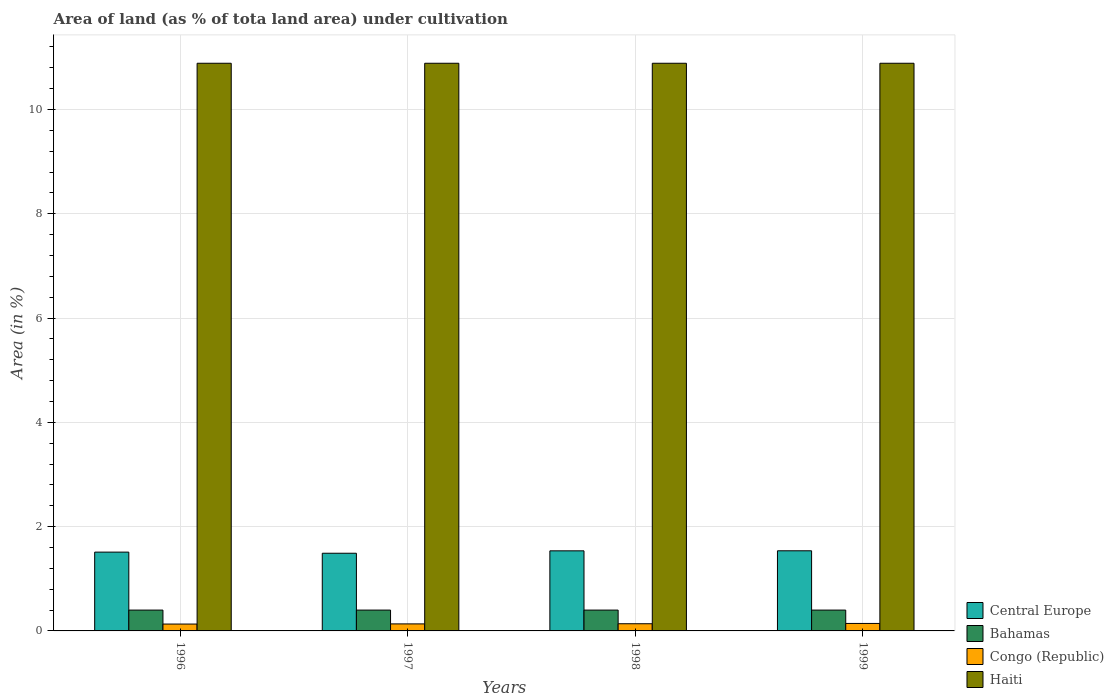How many groups of bars are there?
Provide a short and direct response. 4. Are the number of bars per tick equal to the number of legend labels?
Make the answer very short. Yes. Are the number of bars on each tick of the X-axis equal?
Provide a short and direct response. Yes. How many bars are there on the 2nd tick from the right?
Give a very brief answer. 4. What is the percentage of land under cultivation in Bahamas in 1998?
Keep it short and to the point. 0.4. Across all years, what is the maximum percentage of land under cultivation in Haiti?
Offer a terse response. 10.89. Across all years, what is the minimum percentage of land under cultivation in Central Europe?
Provide a succinct answer. 1.49. In which year was the percentage of land under cultivation in Congo (Republic) maximum?
Offer a terse response. 1999. In which year was the percentage of land under cultivation in Haiti minimum?
Offer a terse response. 1996. What is the total percentage of land under cultivation in Bahamas in the graph?
Offer a very short reply. 1.6. What is the difference between the percentage of land under cultivation in Bahamas in 1996 and that in 1997?
Ensure brevity in your answer.  0. What is the difference between the percentage of land under cultivation in Bahamas in 1998 and the percentage of land under cultivation in Central Europe in 1999?
Your answer should be compact. -1.14. What is the average percentage of land under cultivation in Congo (Republic) per year?
Your response must be concise. 0.14. In the year 1998, what is the difference between the percentage of land under cultivation in Central Europe and percentage of land under cultivation in Bahamas?
Provide a succinct answer. 1.14. What is the ratio of the percentage of land under cultivation in Bahamas in 1997 to that in 1999?
Offer a terse response. 1. What is the difference between the highest and the second highest percentage of land under cultivation in Haiti?
Keep it short and to the point. 0. What is the difference between the highest and the lowest percentage of land under cultivation in Central Europe?
Make the answer very short. 0.05. In how many years, is the percentage of land under cultivation in Congo (Republic) greater than the average percentage of land under cultivation in Congo (Republic) taken over all years?
Offer a very short reply. 2. Is it the case that in every year, the sum of the percentage of land under cultivation in Haiti and percentage of land under cultivation in Central Europe is greater than the sum of percentage of land under cultivation in Bahamas and percentage of land under cultivation in Congo (Republic)?
Your response must be concise. Yes. What does the 4th bar from the left in 1997 represents?
Provide a short and direct response. Haiti. What does the 1st bar from the right in 1997 represents?
Provide a short and direct response. Haiti. Are all the bars in the graph horizontal?
Your answer should be compact. No. What is the difference between two consecutive major ticks on the Y-axis?
Your answer should be compact. 2. Are the values on the major ticks of Y-axis written in scientific E-notation?
Your answer should be compact. No. Does the graph contain grids?
Your answer should be very brief. Yes. What is the title of the graph?
Your response must be concise. Area of land (as % of tota land area) under cultivation. What is the label or title of the X-axis?
Offer a terse response. Years. What is the label or title of the Y-axis?
Your answer should be compact. Area (in %). What is the Area (in %) in Central Europe in 1996?
Provide a succinct answer. 1.51. What is the Area (in %) of Bahamas in 1996?
Your response must be concise. 0.4. What is the Area (in %) in Congo (Republic) in 1996?
Offer a very short reply. 0.13. What is the Area (in %) of Haiti in 1996?
Your response must be concise. 10.89. What is the Area (in %) of Central Europe in 1997?
Offer a very short reply. 1.49. What is the Area (in %) in Bahamas in 1997?
Offer a very short reply. 0.4. What is the Area (in %) of Congo (Republic) in 1997?
Keep it short and to the point. 0.13. What is the Area (in %) of Haiti in 1997?
Give a very brief answer. 10.89. What is the Area (in %) of Central Europe in 1998?
Make the answer very short. 1.54. What is the Area (in %) in Bahamas in 1998?
Ensure brevity in your answer.  0.4. What is the Area (in %) in Congo (Republic) in 1998?
Offer a very short reply. 0.14. What is the Area (in %) of Haiti in 1998?
Your answer should be very brief. 10.89. What is the Area (in %) of Central Europe in 1999?
Ensure brevity in your answer.  1.54. What is the Area (in %) in Bahamas in 1999?
Ensure brevity in your answer.  0.4. What is the Area (in %) in Congo (Republic) in 1999?
Offer a very short reply. 0.14. What is the Area (in %) of Haiti in 1999?
Your answer should be very brief. 10.89. Across all years, what is the maximum Area (in %) of Central Europe?
Your answer should be compact. 1.54. Across all years, what is the maximum Area (in %) of Bahamas?
Your response must be concise. 0.4. Across all years, what is the maximum Area (in %) in Congo (Republic)?
Give a very brief answer. 0.14. Across all years, what is the maximum Area (in %) in Haiti?
Your response must be concise. 10.89. Across all years, what is the minimum Area (in %) of Central Europe?
Give a very brief answer. 1.49. Across all years, what is the minimum Area (in %) of Bahamas?
Provide a succinct answer. 0.4. Across all years, what is the minimum Area (in %) of Congo (Republic)?
Offer a very short reply. 0.13. Across all years, what is the minimum Area (in %) in Haiti?
Give a very brief answer. 10.89. What is the total Area (in %) in Central Europe in the graph?
Your response must be concise. 6.07. What is the total Area (in %) in Bahamas in the graph?
Provide a short and direct response. 1.6. What is the total Area (in %) in Congo (Republic) in the graph?
Make the answer very short. 0.55. What is the total Area (in %) of Haiti in the graph?
Provide a succinct answer. 43.54. What is the difference between the Area (in %) in Central Europe in 1996 and that in 1997?
Your answer should be very brief. 0.02. What is the difference between the Area (in %) of Congo (Republic) in 1996 and that in 1997?
Ensure brevity in your answer.  -0. What is the difference between the Area (in %) in Central Europe in 1996 and that in 1998?
Give a very brief answer. -0.02. What is the difference between the Area (in %) of Congo (Republic) in 1996 and that in 1998?
Your response must be concise. -0.01. What is the difference between the Area (in %) in Central Europe in 1996 and that in 1999?
Your answer should be compact. -0.03. What is the difference between the Area (in %) in Bahamas in 1996 and that in 1999?
Give a very brief answer. 0. What is the difference between the Area (in %) in Congo (Republic) in 1996 and that in 1999?
Offer a very short reply. -0.01. What is the difference between the Area (in %) of Haiti in 1996 and that in 1999?
Give a very brief answer. 0. What is the difference between the Area (in %) in Central Europe in 1997 and that in 1998?
Offer a terse response. -0.05. What is the difference between the Area (in %) in Bahamas in 1997 and that in 1998?
Your response must be concise. 0. What is the difference between the Area (in %) in Congo (Republic) in 1997 and that in 1998?
Offer a very short reply. -0. What is the difference between the Area (in %) in Central Europe in 1997 and that in 1999?
Your response must be concise. -0.05. What is the difference between the Area (in %) in Congo (Republic) in 1997 and that in 1999?
Offer a terse response. -0.01. What is the difference between the Area (in %) in Central Europe in 1998 and that in 1999?
Offer a terse response. -0. What is the difference between the Area (in %) of Bahamas in 1998 and that in 1999?
Provide a short and direct response. 0. What is the difference between the Area (in %) in Congo (Republic) in 1998 and that in 1999?
Make the answer very short. -0.01. What is the difference between the Area (in %) of Haiti in 1998 and that in 1999?
Provide a short and direct response. 0. What is the difference between the Area (in %) of Central Europe in 1996 and the Area (in %) of Bahamas in 1997?
Give a very brief answer. 1.11. What is the difference between the Area (in %) in Central Europe in 1996 and the Area (in %) in Congo (Republic) in 1997?
Provide a short and direct response. 1.38. What is the difference between the Area (in %) in Central Europe in 1996 and the Area (in %) in Haiti in 1997?
Give a very brief answer. -9.37. What is the difference between the Area (in %) of Bahamas in 1996 and the Area (in %) of Congo (Republic) in 1997?
Your answer should be very brief. 0.26. What is the difference between the Area (in %) of Bahamas in 1996 and the Area (in %) of Haiti in 1997?
Offer a very short reply. -10.49. What is the difference between the Area (in %) of Congo (Republic) in 1996 and the Area (in %) of Haiti in 1997?
Your response must be concise. -10.75. What is the difference between the Area (in %) in Central Europe in 1996 and the Area (in %) in Bahamas in 1998?
Your response must be concise. 1.11. What is the difference between the Area (in %) in Central Europe in 1996 and the Area (in %) in Congo (Republic) in 1998?
Your answer should be very brief. 1.37. What is the difference between the Area (in %) of Central Europe in 1996 and the Area (in %) of Haiti in 1998?
Keep it short and to the point. -9.37. What is the difference between the Area (in %) in Bahamas in 1996 and the Area (in %) in Congo (Republic) in 1998?
Ensure brevity in your answer.  0.26. What is the difference between the Area (in %) in Bahamas in 1996 and the Area (in %) in Haiti in 1998?
Provide a short and direct response. -10.49. What is the difference between the Area (in %) in Congo (Republic) in 1996 and the Area (in %) in Haiti in 1998?
Keep it short and to the point. -10.75. What is the difference between the Area (in %) in Central Europe in 1996 and the Area (in %) in Bahamas in 1999?
Keep it short and to the point. 1.11. What is the difference between the Area (in %) of Central Europe in 1996 and the Area (in %) of Congo (Republic) in 1999?
Your answer should be compact. 1.37. What is the difference between the Area (in %) in Central Europe in 1996 and the Area (in %) in Haiti in 1999?
Give a very brief answer. -9.37. What is the difference between the Area (in %) of Bahamas in 1996 and the Area (in %) of Congo (Republic) in 1999?
Keep it short and to the point. 0.26. What is the difference between the Area (in %) in Bahamas in 1996 and the Area (in %) in Haiti in 1999?
Keep it short and to the point. -10.49. What is the difference between the Area (in %) of Congo (Republic) in 1996 and the Area (in %) of Haiti in 1999?
Give a very brief answer. -10.75. What is the difference between the Area (in %) in Central Europe in 1997 and the Area (in %) in Bahamas in 1998?
Keep it short and to the point. 1.09. What is the difference between the Area (in %) of Central Europe in 1997 and the Area (in %) of Congo (Republic) in 1998?
Offer a terse response. 1.35. What is the difference between the Area (in %) in Central Europe in 1997 and the Area (in %) in Haiti in 1998?
Your answer should be very brief. -9.4. What is the difference between the Area (in %) in Bahamas in 1997 and the Area (in %) in Congo (Republic) in 1998?
Keep it short and to the point. 0.26. What is the difference between the Area (in %) of Bahamas in 1997 and the Area (in %) of Haiti in 1998?
Your answer should be very brief. -10.49. What is the difference between the Area (in %) in Congo (Republic) in 1997 and the Area (in %) in Haiti in 1998?
Provide a succinct answer. -10.75. What is the difference between the Area (in %) in Central Europe in 1997 and the Area (in %) in Bahamas in 1999?
Offer a very short reply. 1.09. What is the difference between the Area (in %) in Central Europe in 1997 and the Area (in %) in Congo (Republic) in 1999?
Provide a short and direct response. 1.35. What is the difference between the Area (in %) in Central Europe in 1997 and the Area (in %) in Haiti in 1999?
Keep it short and to the point. -9.4. What is the difference between the Area (in %) of Bahamas in 1997 and the Area (in %) of Congo (Republic) in 1999?
Offer a terse response. 0.26. What is the difference between the Area (in %) of Bahamas in 1997 and the Area (in %) of Haiti in 1999?
Give a very brief answer. -10.49. What is the difference between the Area (in %) in Congo (Republic) in 1997 and the Area (in %) in Haiti in 1999?
Make the answer very short. -10.75. What is the difference between the Area (in %) of Central Europe in 1998 and the Area (in %) of Bahamas in 1999?
Ensure brevity in your answer.  1.14. What is the difference between the Area (in %) in Central Europe in 1998 and the Area (in %) in Congo (Republic) in 1999?
Provide a succinct answer. 1.39. What is the difference between the Area (in %) in Central Europe in 1998 and the Area (in %) in Haiti in 1999?
Keep it short and to the point. -9.35. What is the difference between the Area (in %) in Bahamas in 1998 and the Area (in %) in Congo (Republic) in 1999?
Provide a succinct answer. 0.26. What is the difference between the Area (in %) in Bahamas in 1998 and the Area (in %) in Haiti in 1999?
Keep it short and to the point. -10.49. What is the difference between the Area (in %) of Congo (Republic) in 1998 and the Area (in %) of Haiti in 1999?
Offer a very short reply. -10.75. What is the average Area (in %) of Central Europe per year?
Offer a very short reply. 1.52. What is the average Area (in %) in Bahamas per year?
Ensure brevity in your answer.  0.4. What is the average Area (in %) in Congo (Republic) per year?
Ensure brevity in your answer.  0.14. What is the average Area (in %) of Haiti per year?
Give a very brief answer. 10.89. In the year 1996, what is the difference between the Area (in %) in Central Europe and Area (in %) in Bahamas?
Your answer should be compact. 1.11. In the year 1996, what is the difference between the Area (in %) in Central Europe and Area (in %) in Congo (Republic)?
Your answer should be compact. 1.38. In the year 1996, what is the difference between the Area (in %) of Central Europe and Area (in %) of Haiti?
Give a very brief answer. -9.37. In the year 1996, what is the difference between the Area (in %) of Bahamas and Area (in %) of Congo (Republic)?
Provide a short and direct response. 0.27. In the year 1996, what is the difference between the Area (in %) in Bahamas and Area (in %) in Haiti?
Keep it short and to the point. -10.49. In the year 1996, what is the difference between the Area (in %) in Congo (Republic) and Area (in %) in Haiti?
Make the answer very short. -10.75. In the year 1997, what is the difference between the Area (in %) of Central Europe and Area (in %) of Bahamas?
Make the answer very short. 1.09. In the year 1997, what is the difference between the Area (in %) of Central Europe and Area (in %) of Congo (Republic)?
Your answer should be compact. 1.35. In the year 1997, what is the difference between the Area (in %) in Central Europe and Area (in %) in Haiti?
Your response must be concise. -9.4. In the year 1997, what is the difference between the Area (in %) of Bahamas and Area (in %) of Congo (Republic)?
Ensure brevity in your answer.  0.26. In the year 1997, what is the difference between the Area (in %) of Bahamas and Area (in %) of Haiti?
Provide a succinct answer. -10.49. In the year 1997, what is the difference between the Area (in %) in Congo (Republic) and Area (in %) in Haiti?
Offer a terse response. -10.75. In the year 1998, what is the difference between the Area (in %) in Central Europe and Area (in %) in Bahamas?
Offer a very short reply. 1.14. In the year 1998, what is the difference between the Area (in %) of Central Europe and Area (in %) of Congo (Republic)?
Your answer should be very brief. 1.4. In the year 1998, what is the difference between the Area (in %) in Central Europe and Area (in %) in Haiti?
Offer a very short reply. -9.35. In the year 1998, what is the difference between the Area (in %) in Bahamas and Area (in %) in Congo (Republic)?
Your answer should be compact. 0.26. In the year 1998, what is the difference between the Area (in %) of Bahamas and Area (in %) of Haiti?
Provide a short and direct response. -10.49. In the year 1998, what is the difference between the Area (in %) of Congo (Republic) and Area (in %) of Haiti?
Your answer should be compact. -10.75. In the year 1999, what is the difference between the Area (in %) in Central Europe and Area (in %) in Bahamas?
Your response must be concise. 1.14. In the year 1999, what is the difference between the Area (in %) of Central Europe and Area (in %) of Congo (Republic)?
Provide a succinct answer. 1.39. In the year 1999, what is the difference between the Area (in %) of Central Europe and Area (in %) of Haiti?
Ensure brevity in your answer.  -9.35. In the year 1999, what is the difference between the Area (in %) in Bahamas and Area (in %) in Congo (Republic)?
Provide a succinct answer. 0.26. In the year 1999, what is the difference between the Area (in %) of Bahamas and Area (in %) of Haiti?
Ensure brevity in your answer.  -10.49. In the year 1999, what is the difference between the Area (in %) in Congo (Republic) and Area (in %) in Haiti?
Offer a very short reply. -10.74. What is the ratio of the Area (in %) of Central Europe in 1996 to that in 1997?
Your answer should be compact. 1.01. What is the ratio of the Area (in %) in Bahamas in 1996 to that in 1997?
Ensure brevity in your answer.  1. What is the ratio of the Area (in %) in Congo (Republic) in 1996 to that in 1997?
Your answer should be very brief. 0.98. What is the ratio of the Area (in %) of Congo (Republic) in 1996 to that in 1998?
Provide a short and direct response. 0.96. What is the ratio of the Area (in %) of Central Europe in 1996 to that in 1999?
Your response must be concise. 0.98. What is the ratio of the Area (in %) in Bahamas in 1996 to that in 1999?
Your answer should be compact. 1. What is the ratio of the Area (in %) in Congo (Republic) in 1996 to that in 1999?
Provide a short and direct response. 0.92. What is the ratio of the Area (in %) in Central Europe in 1997 to that in 1998?
Provide a succinct answer. 0.97. What is the ratio of the Area (in %) in Congo (Republic) in 1997 to that in 1998?
Ensure brevity in your answer.  0.98. What is the ratio of the Area (in %) in Haiti in 1997 to that in 1998?
Offer a terse response. 1. What is the ratio of the Area (in %) of Central Europe in 1997 to that in 1999?
Provide a short and direct response. 0.97. What is the ratio of the Area (in %) in Congo (Republic) in 1997 to that in 1999?
Your response must be concise. 0.94. What is the ratio of the Area (in %) in Congo (Republic) in 1998 to that in 1999?
Keep it short and to the point. 0.96. What is the ratio of the Area (in %) in Haiti in 1998 to that in 1999?
Keep it short and to the point. 1. What is the difference between the highest and the second highest Area (in %) of Central Europe?
Your answer should be very brief. 0. What is the difference between the highest and the second highest Area (in %) of Bahamas?
Your answer should be very brief. 0. What is the difference between the highest and the second highest Area (in %) in Congo (Republic)?
Make the answer very short. 0.01. What is the difference between the highest and the second highest Area (in %) of Haiti?
Your response must be concise. 0. What is the difference between the highest and the lowest Area (in %) of Central Europe?
Your answer should be compact. 0.05. What is the difference between the highest and the lowest Area (in %) of Bahamas?
Your answer should be compact. 0. What is the difference between the highest and the lowest Area (in %) in Congo (Republic)?
Offer a terse response. 0.01. 